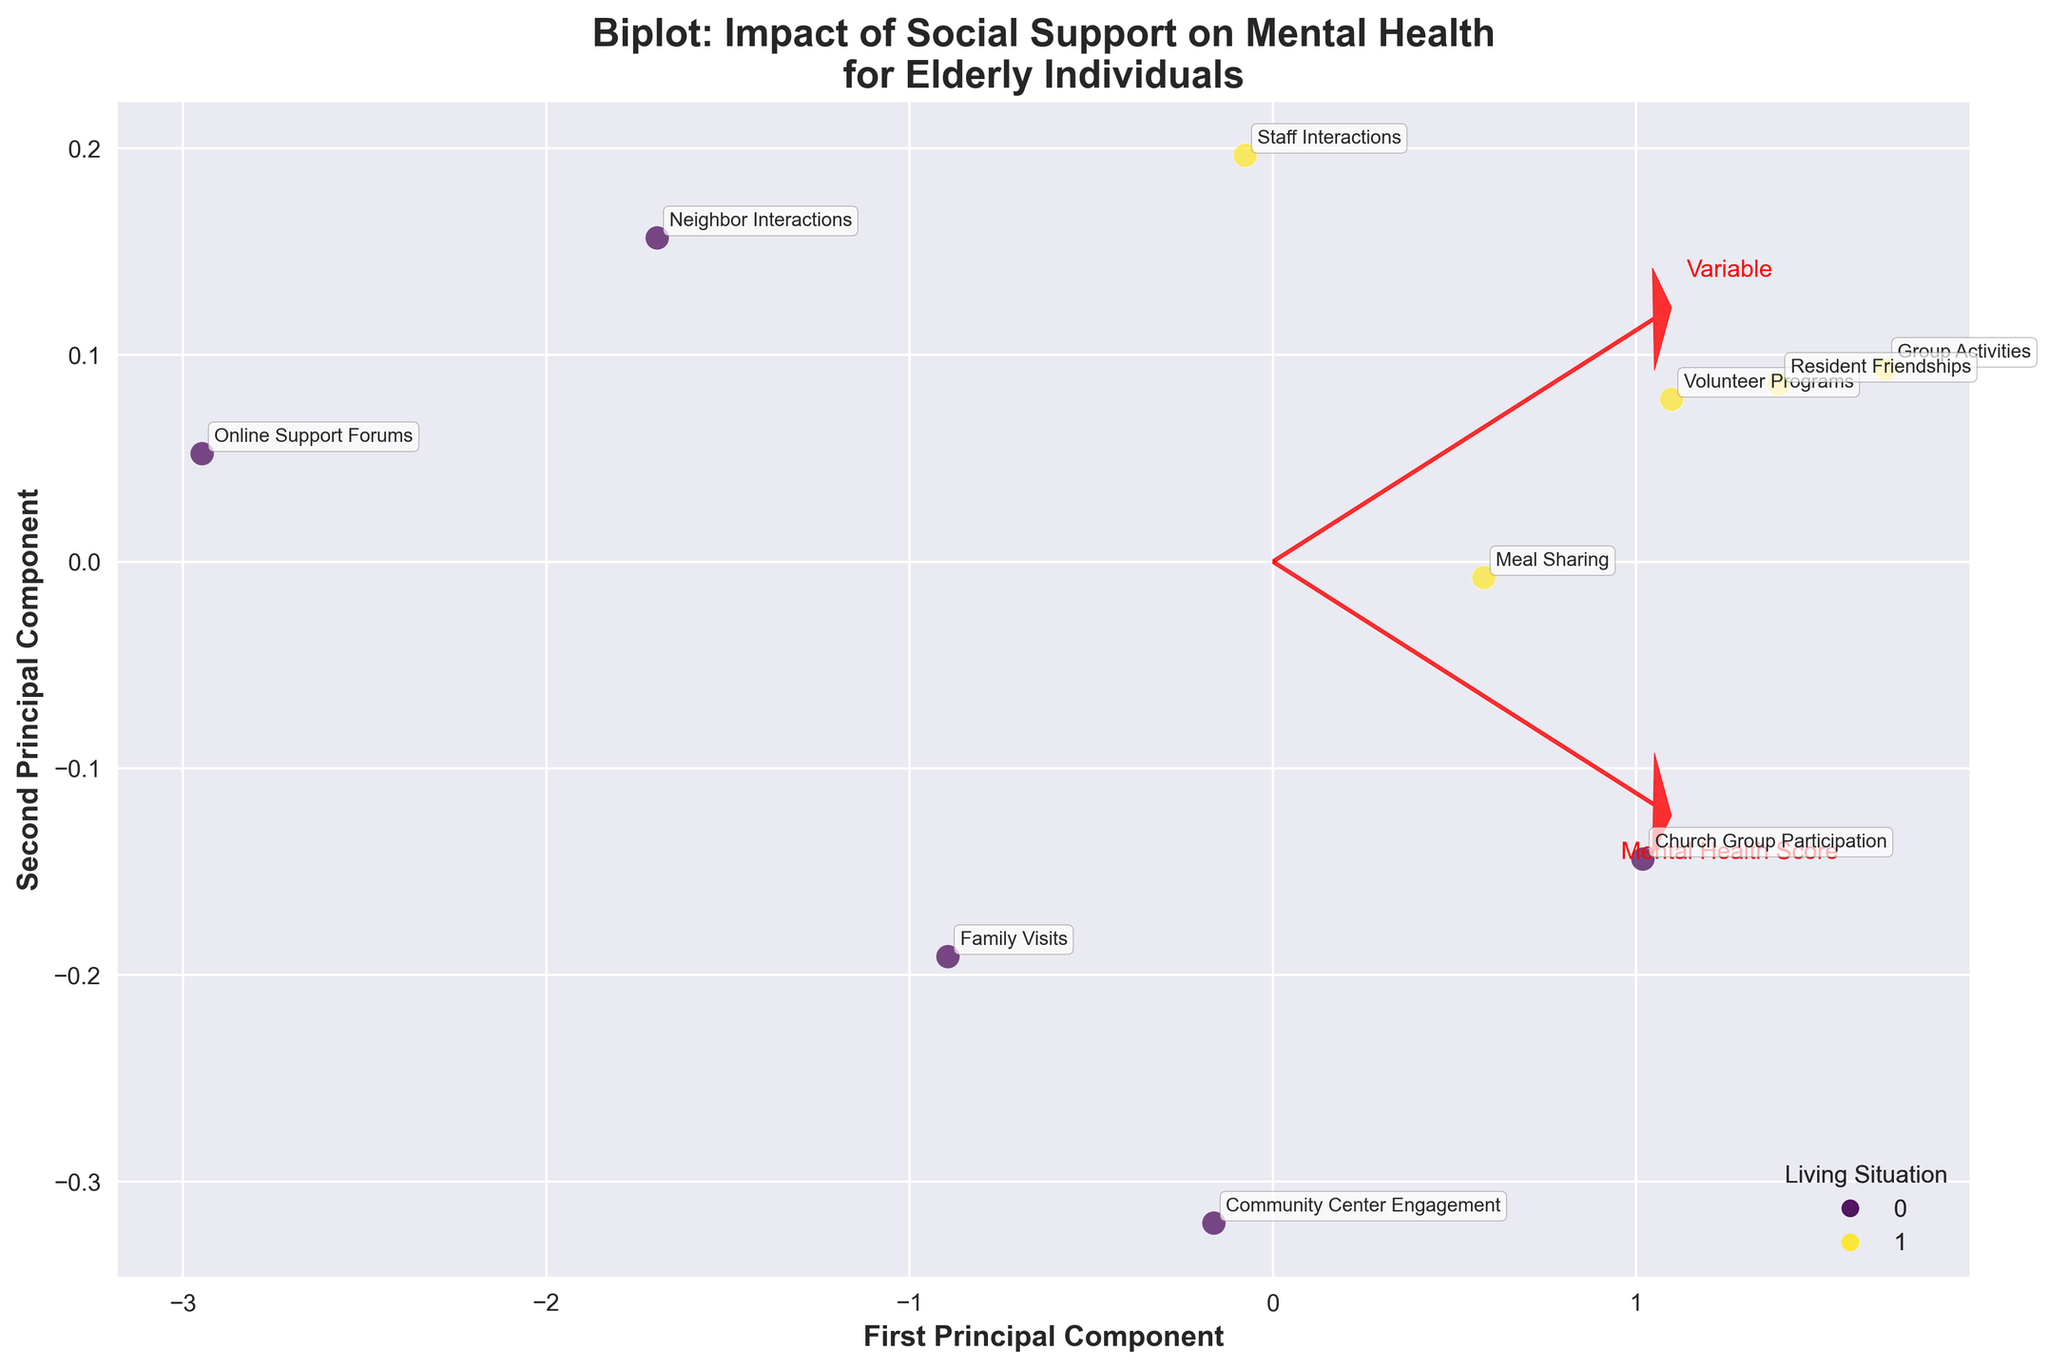what is the title of the figure? The title of the figure is the text that appears at the top of the plot, it usually describes what the figure is about. Here, it's written in bold above the plot area.
Answer: Biplot: Impact of Social Support on Mental Health for Elderly Individuals What do the axes represent? Axes in a biplot represent the principal components derived from the data. In this figure, the x-axis and y-axis are labeled with descriptive text explaining these principal components.
Answer: First Principal Component and Second Principal Component How many data points represent individuals living alone? Data points can be distinguished by color and the legend indicating the living situation. Count the points corresponding to "Alone" based on color.
Answer: 5 Which living situation has higher mental health scores on average? By observing the positions of the data points on the x-axis, we assess where the cluster of points for each living situation tends to lie. "Alone" has points with scores lower on average, while "Assisted Living" has many points lying higher.
Answer: Assisted Living What is represented by the arrows on the plot? In a biplot, arrows indicate the direction and strength of variables in the original data space. The arrows denote how the variables are loaded onto the principal components.
Answer: Direction and strength of variables Which type of social support has the highest impact on mental health for those living alone? Look for the data point labeled close to both the high scales of Mental Health Score and Social Support Score on the figure for individuals living alone.
Answer: Church Group Participation How do social support scores compare between 'Community Center Engagement' and 'Volunteer Programs'? Compare the positions of the corresponding data points along the y-axis to see which lies higher.
Answer: Volunteer Programs has a higher social support score than Community Center Engagement Which living situation shows a greater variance in mental health scores? Variance can be visually assessed by looking at the spread of the data points along the Mental Health Score (x-axis) for each group. The wider the spread, the greater the variance.
Answer: Alone Are resident friendships or neighbor interactions more beneficial for mental health in elderly individuals? By observing the direction and length of the arrows corresponding to each variable related to the Mental Health Score axis, we can determine which is more beneficial.
Answer: Resident Friendships What is the relative position of 'Online Support Forums' in terms of social support for those living alone? Locate where the 'Online Support Forums' data point lies along the y-axis to determine its social support score.
Answer: Lower Which types of social support are closely related based on their positions in the figure? Assess the figure for arrows or data points that lie close to each other, indicating similar direction and influence.
Answer: Group Activities and Resident Friendships 